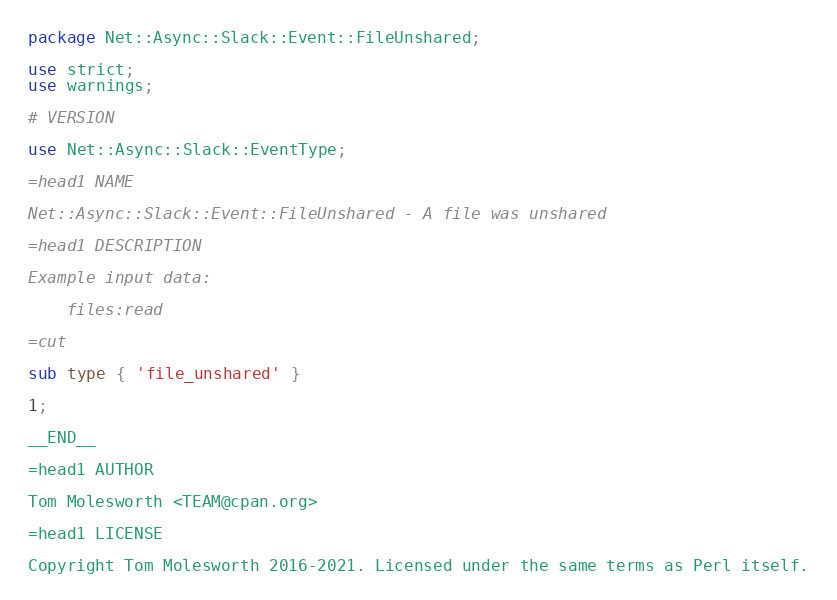<code> <loc_0><loc_0><loc_500><loc_500><_Perl_>package Net::Async::Slack::Event::FileUnshared;

use strict;
use warnings;

# VERSION

use Net::Async::Slack::EventType;

=head1 NAME

Net::Async::Slack::Event::FileUnshared - A file was unshared

=head1 DESCRIPTION

Example input data:

    files:read

=cut

sub type { 'file_unshared' }

1;

__END__

=head1 AUTHOR

Tom Molesworth <TEAM@cpan.org>

=head1 LICENSE

Copyright Tom Molesworth 2016-2021. Licensed under the same terms as Perl itself.
</code> 